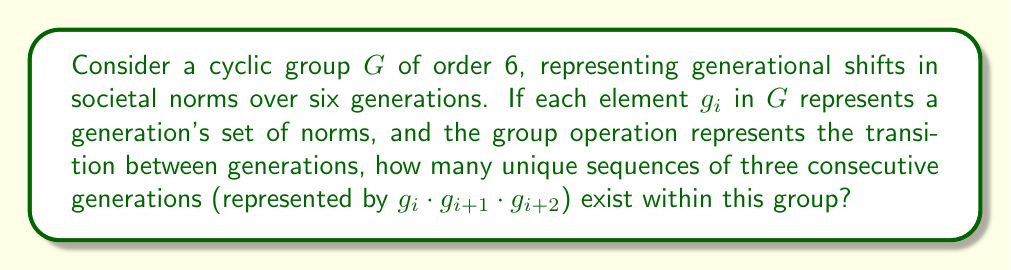Teach me how to tackle this problem. To solve this problem, we need to understand the structure of a cyclic group of order 6 and how it relates to generational shifts in societal norms:

1) A cyclic group of order 6 can be represented as $G = \{e, g, g^2, g^3, g^4, g^5\}$, where $e$ is the identity element and $g$ is the generator of the group.

2) In our context, each element represents a generation's set of norms, and the group operation represents the transition between generations.

3) We are looking for unique sequences of three consecutive generations, which can be represented as $g_i \cdot g_{i+1} \cdot g_{i+2}$, where $i \in \{0, 1, 2, 3, 4, 5\}$ and the indices are taken modulo 6.

4) Let's list out all possible sequences:
   - $e \cdot g \cdot g^2$
   - $g \cdot g^2 \cdot g^3$
   - $g^2 \cdot g^3 \cdot g^4$
   - $g^3 \cdot g^4 \cdot g^5$
   - $g^4 \cdot g^5 \cdot e$
   - $g^5 \cdot e \cdot g$

5) Each of these sequences represents a unique transition of norms over three generations.

6) Due to the cyclic nature of the group, these 6 sequences are all the unique possibilities.

This result shows that despite the seemingly linear progression of generations, the cyclic nature of societal norms creates a finite number of unique transitional patterns, challenging the notion of continuous, linear social progress often assumed in studies of long-term social change.
Answer: There are 6 unique sequences of three consecutive generations in the cyclic group $G$ of order 6. 